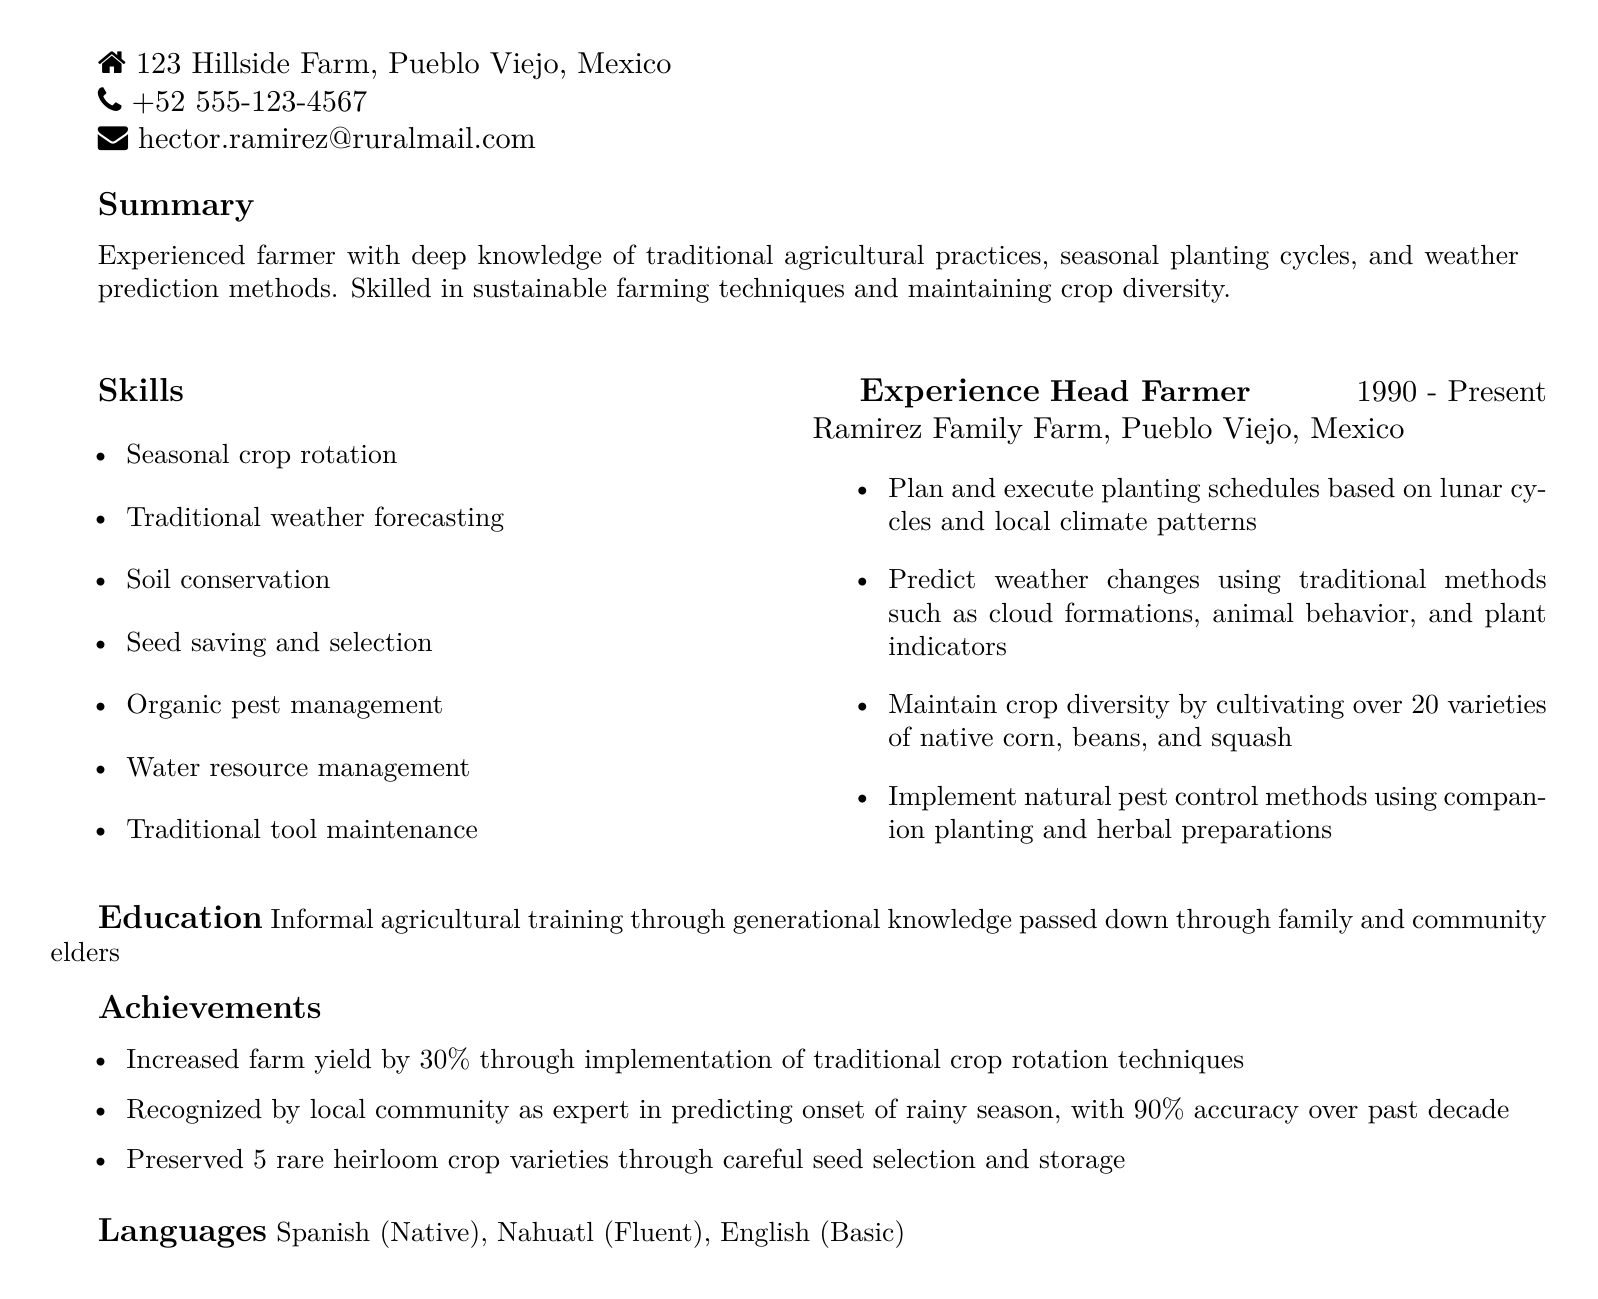What is the full name of the farmer? The document lists the farmer's full name at the beginning, which is Hector Ramirez.
Answer: Hector Ramirez What is the location of the farm? The address provided in the document specifies the location of the farm as 123 Hillside Farm, Pueblo Viejo, Mexico.
Answer: 123 Hillside Farm, Pueblo Viejo, Mexico How many varieties of native crops does Hector cultivate? The experience section mentions that he cultivates over 20 varieties of native corn, beans, and squash, which can be compared against his skills in maintaining crop diversity.
Answer: 20 What award has Hector received from the local community? The achievements section indicates that Hector has been recognized as an expert in predicting the onset of the rainy season, reflecting a community acknowledgment of his skills.
Answer: Expert in predicting rainy season In what year did Hector start farming? The experience section denotes that he has been the Head Farmer since 1990, marking the initiation of his farming career.
Answer: 1990 What type of education has Hector received? The education section specifies that he has informal agricultural training passed down through generational knowledge from family and community elders.
Answer: Informal agricultural training How much did Hector increase his farm yield by? The document notes an increase of 30% in farm yield through the implementation of traditional crop rotation techniques, showcasing his effectiveness in farming practices.
Answer: 30% What languages does Hector speak? The languages section provides a list of languages he is proficient in, which helps to understand his communication skills.
Answer: Spanish, Nahuatl, English What method does Hector use for weather prediction? The experience section outlines that he uses traditional methods such as cloud formations and animal behavior for predicting weather changes, indicating the diversity of his skills.
Answer: Traditional methods 